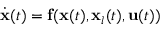Convert formula to latex. <formula><loc_0><loc_0><loc_500><loc_500>\begin{array} { r } { \dot { x } ( t ) = f ( x ( t ) , x _ { l } ( t ) , u ( t ) ) } \end{array}</formula> 